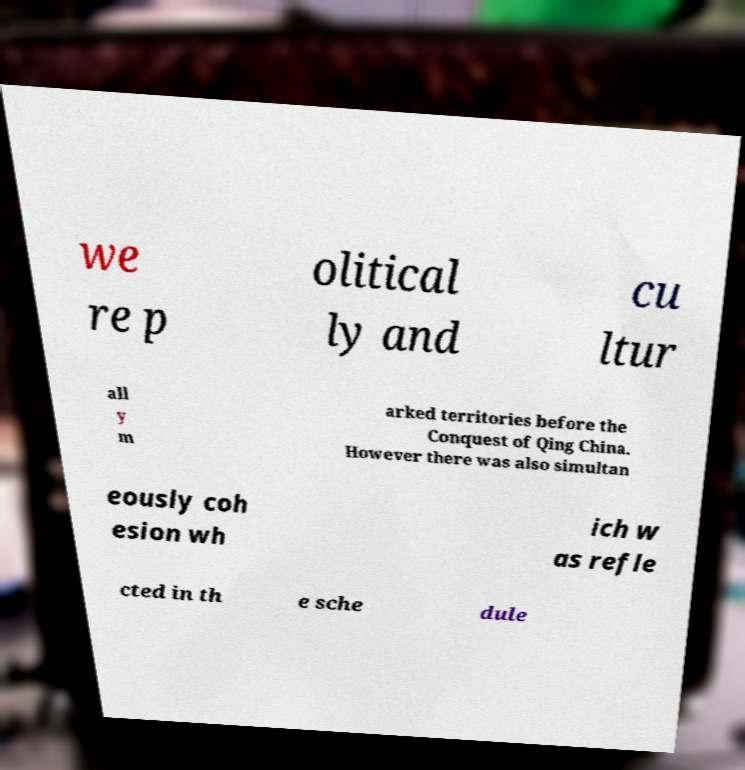Please read and relay the text visible in this image. What does it say? we re p olitical ly and cu ltur all y m arked territories before the Conquest of Qing China. However there was also simultan eously coh esion wh ich w as refle cted in th e sche dule 